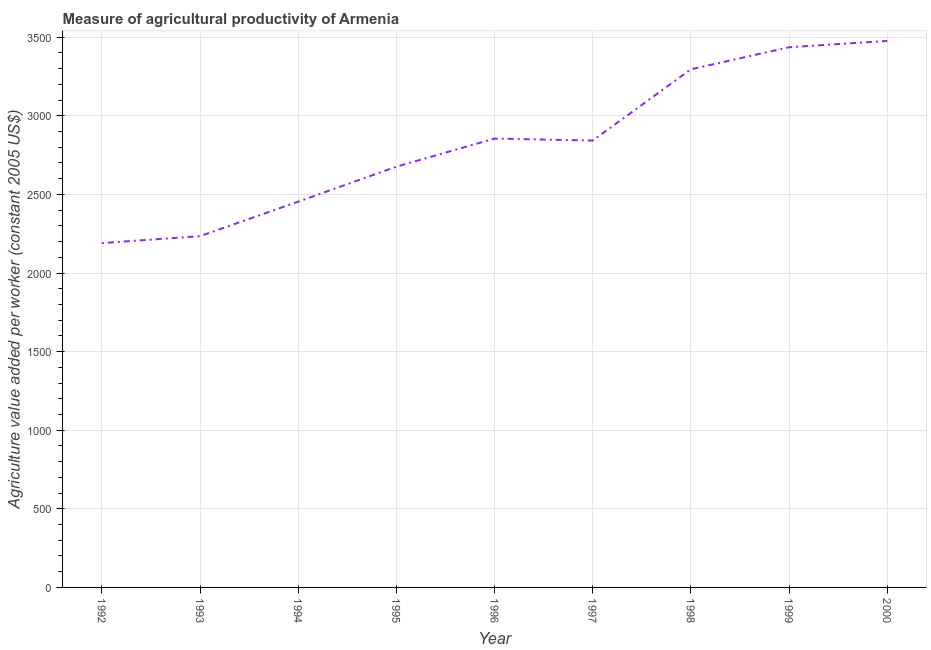What is the agriculture value added per worker in 1994?
Provide a short and direct response. 2453.77. Across all years, what is the maximum agriculture value added per worker?
Offer a terse response. 3476.25. Across all years, what is the minimum agriculture value added per worker?
Your answer should be compact. 2190.34. In which year was the agriculture value added per worker maximum?
Give a very brief answer. 2000. What is the sum of the agriculture value added per worker?
Offer a terse response. 2.55e+04. What is the difference between the agriculture value added per worker in 1995 and 2000?
Keep it short and to the point. -799.84. What is the average agriculture value added per worker per year?
Give a very brief answer. 2828.99. What is the median agriculture value added per worker?
Provide a short and direct response. 2842.7. What is the ratio of the agriculture value added per worker in 1996 to that in 1999?
Your response must be concise. 0.83. Is the difference between the agriculture value added per worker in 1998 and 2000 greater than the difference between any two years?
Provide a short and direct response. No. What is the difference between the highest and the second highest agriculture value added per worker?
Your answer should be compact. 40.32. What is the difference between the highest and the lowest agriculture value added per worker?
Your response must be concise. 1285.91. In how many years, is the agriculture value added per worker greater than the average agriculture value added per worker taken over all years?
Provide a short and direct response. 5. Does the agriculture value added per worker monotonically increase over the years?
Your response must be concise. No. How many years are there in the graph?
Your answer should be very brief. 9. Does the graph contain any zero values?
Give a very brief answer. No. What is the title of the graph?
Make the answer very short. Measure of agricultural productivity of Armenia. What is the label or title of the X-axis?
Your answer should be compact. Year. What is the label or title of the Y-axis?
Make the answer very short. Agriculture value added per worker (constant 2005 US$). What is the Agriculture value added per worker (constant 2005 US$) in 1992?
Provide a short and direct response. 2190.34. What is the Agriculture value added per worker (constant 2005 US$) of 1993?
Give a very brief answer. 2234.49. What is the Agriculture value added per worker (constant 2005 US$) in 1994?
Offer a terse response. 2453.77. What is the Agriculture value added per worker (constant 2005 US$) of 1995?
Offer a very short reply. 2676.41. What is the Agriculture value added per worker (constant 2005 US$) of 1996?
Provide a succinct answer. 2855.14. What is the Agriculture value added per worker (constant 2005 US$) in 1997?
Ensure brevity in your answer.  2842.7. What is the Agriculture value added per worker (constant 2005 US$) of 1998?
Your answer should be very brief. 3295.91. What is the Agriculture value added per worker (constant 2005 US$) in 1999?
Ensure brevity in your answer.  3435.93. What is the Agriculture value added per worker (constant 2005 US$) in 2000?
Keep it short and to the point. 3476.25. What is the difference between the Agriculture value added per worker (constant 2005 US$) in 1992 and 1993?
Provide a short and direct response. -44.15. What is the difference between the Agriculture value added per worker (constant 2005 US$) in 1992 and 1994?
Your response must be concise. -263.43. What is the difference between the Agriculture value added per worker (constant 2005 US$) in 1992 and 1995?
Make the answer very short. -486.07. What is the difference between the Agriculture value added per worker (constant 2005 US$) in 1992 and 1996?
Provide a short and direct response. -664.8. What is the difference between the Agriculture value added per worker (constant 2005 US$) in 1992 and 1997?
Make the answer very short. -652.36. What is the difference between the Agriculture value added per worker (constant 2005 US$) in 1992 and 1998?
Provide a short and direct response. -1105.57. What is the difference between the Agriculture value added per worker (constant 2005 US$) in 1992 and 1999?
Provide a succinct answer. -1245.59. What is the difference between the Agriculture value added per worker (constant 2005 US$) in 1992 and 2000?
Your answer should be very brief. -1285.91. What is the difference between the Agriculture value added per worker (constant 2005 US$) in 1993 and 1994?
Keep it short and to the point. -219.28. What is the difference between the Agriculture value added per worker (constant 2005 US$) in 1993 and 1995?
Give a very brief answer. -441.92. What is the difference between the Agriculture value added per worker (constant 2005 US$) in 1993 and 1996?
Provide a succinct answer. -620.65. What is the difference between the Agriculture value added per worker (constant 2005 US$) in 1993 and 1997?
Your answer should be very brief. -608.21. What is the difference between the Agriculture value added per worker (constant 2005 US$) in 1993 and 1998?
Your answer should be compact. -1061.42. What is the difference between the Agriculture value added per worker (constant 2005 US$) in 1993 and 1999?
Your response must be concise. -1201.44. What is the difference between the Agriculture value added per worker (constant 2005 US$) in 1993 and 2000?
Your response must be concise. -1241.76. What is the difference between the Agriculture value added per worker (constant 2005 US$) in 1994 and 1995?
Give a very brief answer. -222.63. What is the difference between the Agriculture value added per worker (constant 2005 US$) in 1994 and 1996?
Offer a terse response. -401.37. What is the difference between the Agriculture value added per worker (constant 2005 US$) in 1994 and 1997?
Your answer should be compact. -388.93. What is the difference between the Agriculture value added per worker (constant 2005 US$) in 1994 and 1998?
Keep it short and to the point. -842.14. What is the difference between the Agriculture value added per worker (constant 2005 US$) in 1994 and 1999?
Keep it short and to the point. -982.16. What is the difference between the Agriculture value added per worker (constant 2005 US$) in 1994 and 2000?
Your answer should be compact. -1022.48. What is the difference between the Agriculture value added per worker (constant 2005 US$) in 1995 and 1996?
Provide a short and direct response. -178.73. What is the difference between the Agriculture value added per worker (constant 2005 US$) in 1995 and 1997?
Ensure brevity in your answer.  -166.29. What is the difference between the Agriculture value added per worker (constant 2005 US$) in 1995 and 1998?
Make the answer very short. -619.5. What is the difference between the Agriculture value added per worker (constant 2005 US$) in 1995 and 1999?
Provide a short and direct response. -759.52. What is the difference between the Agriculture value added per worker (constant 2005 US$) in 1995 and 2000?
Provide a short and direct response. -799.84. What is the difference between the Agriculture value added per worker (constant 2005 US$) in 1996 and 1997?
Offer a terse response. 12.44. What is the difference between the Agriculture value added per worker (constant 2005 US$) in 1996 and 1998?
Provide a short and direct response. -440.77. What is the difference between the Agriculture value added per worker (constant 2005 US$) in 1996 and 1999?
Provide a succinct answer. -580.79. What is the difference between the Agriculture value added per worker (constant 2005 US$) in 1996 and 2000?
Offer a terse response. -621.11. What is the difference between the Agriculture value added per worker (constant 2005 US$) in 1997 and 1998?
Keep it short and to the point. -453.21. What is the difference between the Agriculture value added per worker (constant 2005 US$) in 1997 and 1999?
Give a very brief answer. -593.23. What is the difference between the Agriculture value added per worker (constant 2005 US$) in 1997 and 2000?
Your answer should be very brief. -633.55. What is the difference between the Agriculture value added per worker (constant 2005 US$) in 1998 and 1999?
Your answer should be very brief. -140.02. What is the difference between the Agriculture value added per worker (constant 2005 US$) in 1998 and 2000?
Provide a succinct answer. -180.34. What is the difference between the Agriculture value added per worker (constant 2005 US$) in 1999 and 2000?
Offer a very short reply. -40.32. What is the ratio of the Agriculture value added per worker (constant 2005 US$) in 1992 to that in 1994?
Your answer should be compact. 0.89. What is the ratio of the Agriculture value added per worker (constant 2005 US$) in 1992 to that in 1995?
Make the answer very short. 0.82. What is the ratio of the Agriculture value added per worker (constant 2005 US$) in 1992 to that in 1996?
Your answer should be very brief. 0.77. What is the ratio of the Agriculture value added per worker (constant 2005 US$) in 1992 to that in 1997?
Offer a very short reply. 0.77. What is the ratio of the Agriculture value added per worker (constant 2005 US$) in 1992 to that in 1998?
Your answer should be compact. 0.67. What is the ratio of the Agriculture value added per worker (constant 2005 US$) in 1992 to that in 1999?
Offer a very short reply. 0.64. What is the ratio of the Agriculture value added per worker (constant 2005 US$) in 1992 to that in 2000?
Your answer should be compact. 0.63. What is the ratio of the Agriculture value added per worker (constant 2005 US$) in 1993 to that in 1994?
Provide a short and direct response. 0.91. What is the ratio of the Agriculture value added per worker (constant 2005 US$) in 1993 to that in 1995?
Give a very brief answer. 0.83. What is the ratio of the Agriculture value added per worker (constant 2005 US$) in 1993 to that in 1996?
Your answer should be compact. 0.78. What is the ratio of the Agriculture value added per worker (constant 2005 US$) in 1993 to that in 1997?
Provide a short and direct response. 0.79. What is the ratio of the Agriculture value added per worker (constant 2005 US$) in 1993 to that in 1998?
Ensure brevity in your answer.  0.68. What is the ratio of the Agriculture value added per worker (constant 2005 US$) in 1993 to that in 1999?
Keep it short and to the point. 0.65. What is the ratio of the Agriculture value added per worker (constant 2005 US$) in 1993 to that in 2000?
Provide a succinct answer. 0.64. What is the ratio of the Agriculture value added per worker (constant 2005 US$) in 1994 to that in 1995?
Keep it short and to the point. 0.92. What is the ratio of the Agriculture value added per worker (constant 2005 US$) in 1994 to that in 1996?
Your answer should be very brief. 0.86. What is the ratio of the Agriculture value added per worker (constant 2005 US$) in 1994 to that in 1997?
Offer a terse response. 0.86. What is the ratio of the Agriculture value added per worker (constant 2005 US$) in 1994 to that in 1998?
Provide a succinct answer. 0.74. What is the ratio of the Agriculture value added per worker (constant 2005 US$) in 1994 to that in 1999?
Keep it short and to the point. 0.71. What is the ratio of the Agriculture value added per worker (constant 2005 US$) in 1994 to that in 2000?
Provide a succinct answer. 0.71. What is the ratio of the Agriculture value added per worker (constant 2005 US$) in 1995 to that in 1996?
Provide a short and direct response. 0.94. What is the ratio of the Agriculture value added per worker (constant 2005 US$) in 1995 to that in 1997?
Your answer should be compact. 0.94. What is the ratio of the Agriculture value added per worker (constant 2005 US$) in 1995 to that in 1998?
Provide a short and direct response. 0.81. What is the ratio of the Agriculture value added per worker (constant 2005 US$) in 1995 to that in 1999?
Ensure brevity in your answer.  0.78. What is the ratio of the Agriculture value added per worker (constant 2005 US$) in 1995 to that in 2000?
Provide a succinct answer. 0.77. What is the ratio of the Agriculture value added per worker (constant 2005 US$) in 1996 to that in 1998?
Keep it short and to the point. 0.87. What is the ratio of the Agriculture value added per worker (constant 2005 US$) in 1996 to that in 1999?
Offer a very short reply. 0.83. What is the ratio of the Agriculture value added per worker (constant 2005 US$) in 1996 to that in 2000?
Your answer should be compact. 0.82. What is the ratio of the Agriculture value added per worker (constant 2005 US$) in 1997 to that in 1998?
Keep it short and to the point. 0.86. What is the ratio of the Agriculture value added per worker (constant 2005 US$) in 1997 to that in 1999?
Your answer should be very brief. 0.83. What is the ratio of the Agriculture value added per worker (constant 2005 US$) in 1997 to that in 2000?
Your answer should be compact. 0.82. What is the ratio of the Agriculture value added per worker (constant 2005 US$) in 1998 to that in 2000?
Provide a succinct answer. 0.95. What is the ratio of the Agriculture value added per worker (constant 2005 US$) in 1999 to that in 2000?
Provide a short and direct response. 0.99. 